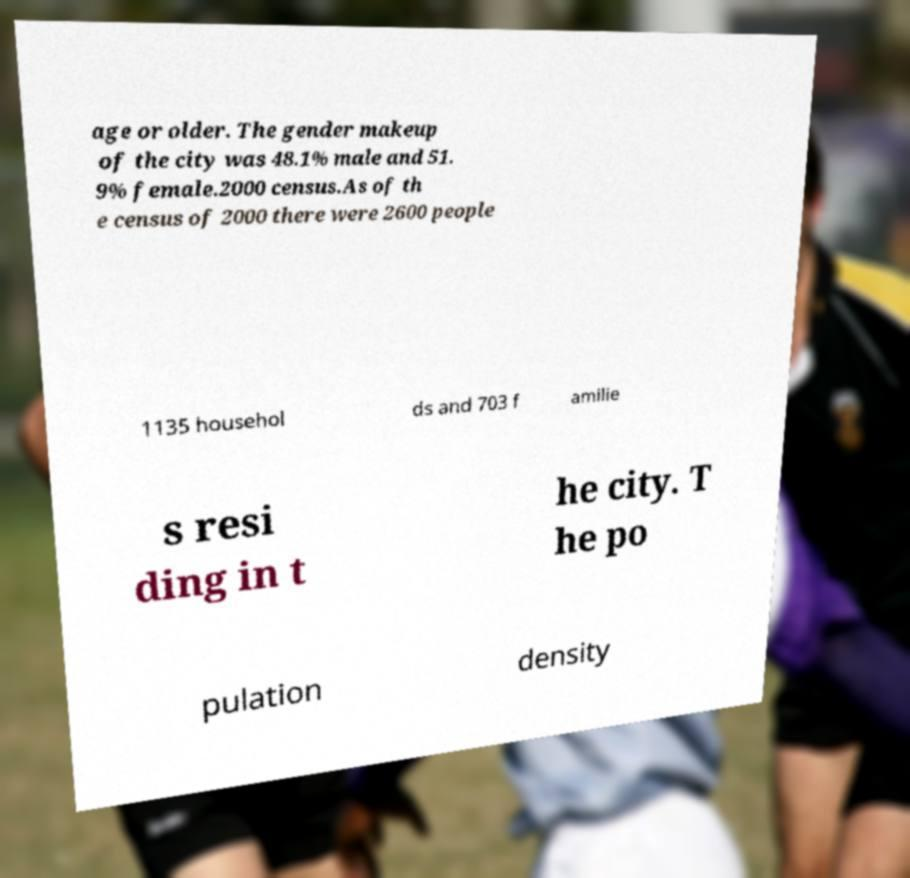Could you assist in decoding the text presented in this image and type it out clearly? age or older. The gender makeup of the city was 48.1% male and 51. 9% female.2000 census.As of th e census of 2000 there were 2600 people 1135 househol ds and 703 f amilie s resi ding in t he city. T he po pulation density 